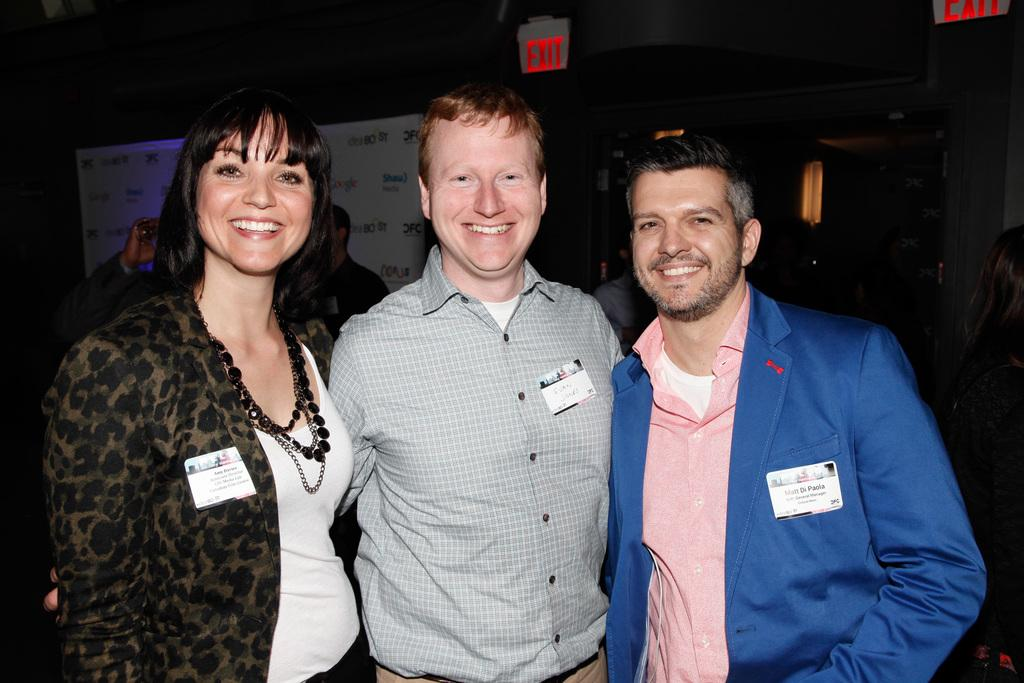How many people are in the image? There are people in the image. Can you describe the expressions on their faces? Three people are smiling. What else can be seen in the image besides the people? There is a poster with text and exit boards visible on the roof. What type of lunch is being served to the geese in the image? There are no geese or lunch present in the image. 